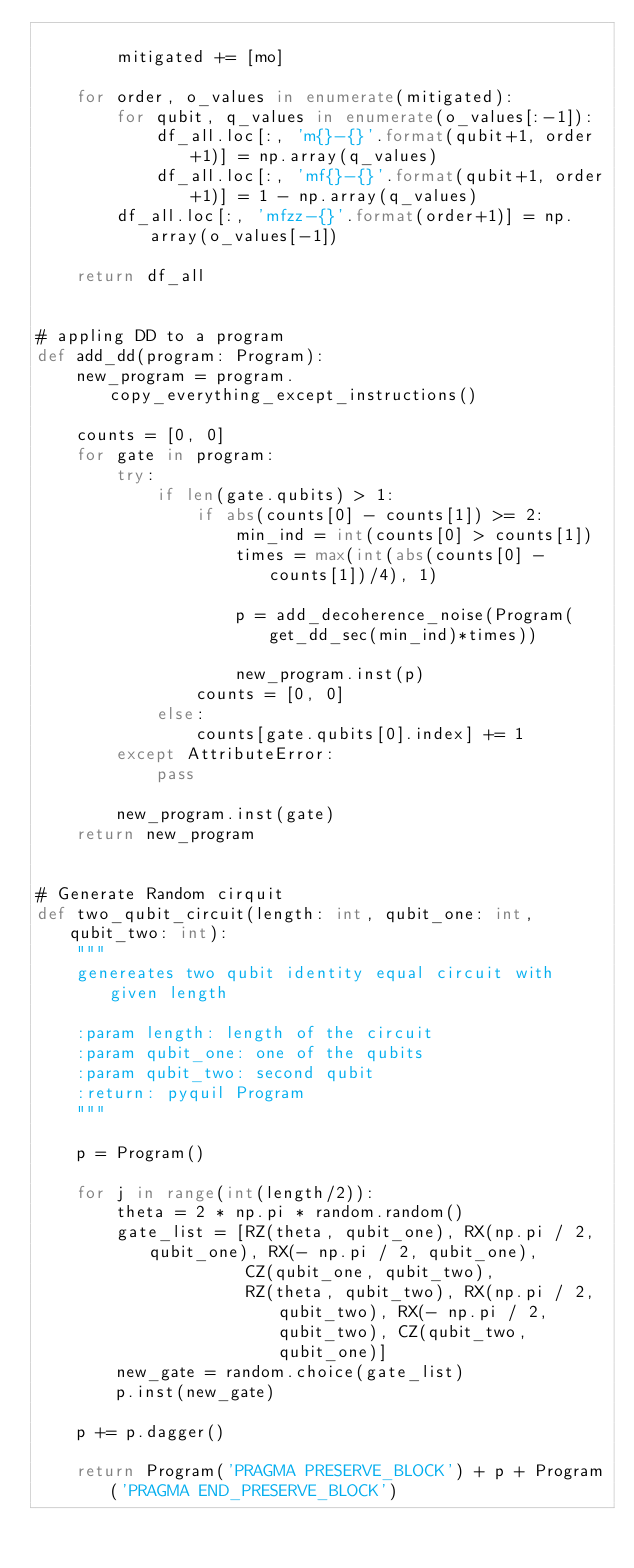Convert code to text. <code><loc_0><loc_0><loc_500><loc_500><_Python_>
        mitigated += [mo]

    for order, o_values in enumerate(mitigated):
        for qubit, q_values in enumerate(o_values[:-1]):
            df_all.loc[:, 'm{}-{}'.format(qubit+1, order+1)] = np.array(q_values)
            df_all.loc[:, 'mf{}-{}'.format(qubit+1, order+1)] = 1 - np.array(q_values)
        df_all.loc[:, 'mfzz-{}'.format(order+1)] = np.array(o_values[-1])

    return df_all


# appling DD to a program
def add_dd(program: Program):
    new_program = program.copy_everything_except_instructions()

    counts = [0, 0]
    for gate in program:
        try:
            if len(gate.qubits) > 1:
                if abs(counts[0] - counts[1]) >= 2:
                    min_ind = int(counts[0] > counts[1])
                    times = max(int(abs(counts[0] - counts[1])/4), 1)

                    p = add_decoherence_noise(Program(get_dd_sec(min_ind)*times))

                    new_program.inst(p)
                counts = [0, 0]
            else:
                counts[gate.qubits[0].index] += 1
        except AttributeError:
            pass

        new_program.inst(gate)
    return new_program


# Generate Random cirquit
def two_qubit_circuit(length: int, qubit_one: int, qubit_two: int):
    """
    genereates two qubit identity equal circuit with given length

    :param length: length of the circuit
    :param qubit_one: one of the qubits
    :param qubit_two: second qubit
    :return: pyquil Program
    """

    p = Program()

    for j in range(int(length/2)):
        theta = 2 * np.pi * random.random()
        gate_list = [RZ(theta, qubit_one), RX(np.pi / 2, qubit_one), RX(- np.pi / 2, qubit_one),
                     CZ(qubit_one, qubit_two),
                     RZ(theta, qubit_two), RX(np.pi / 2, qubit_two), RX(- np.pi / 2, qubit_two), CZ(qubit_two, qubit_one)]
        new_gate = random.choice(gate_list)
        p.inst(new_gate)

    p += p.dagger()

    return Program('PRAGMA PRESERVE_BLOCK') + p + Program('PRAGMA END_PRESERVE_BLOCK')
</code> 